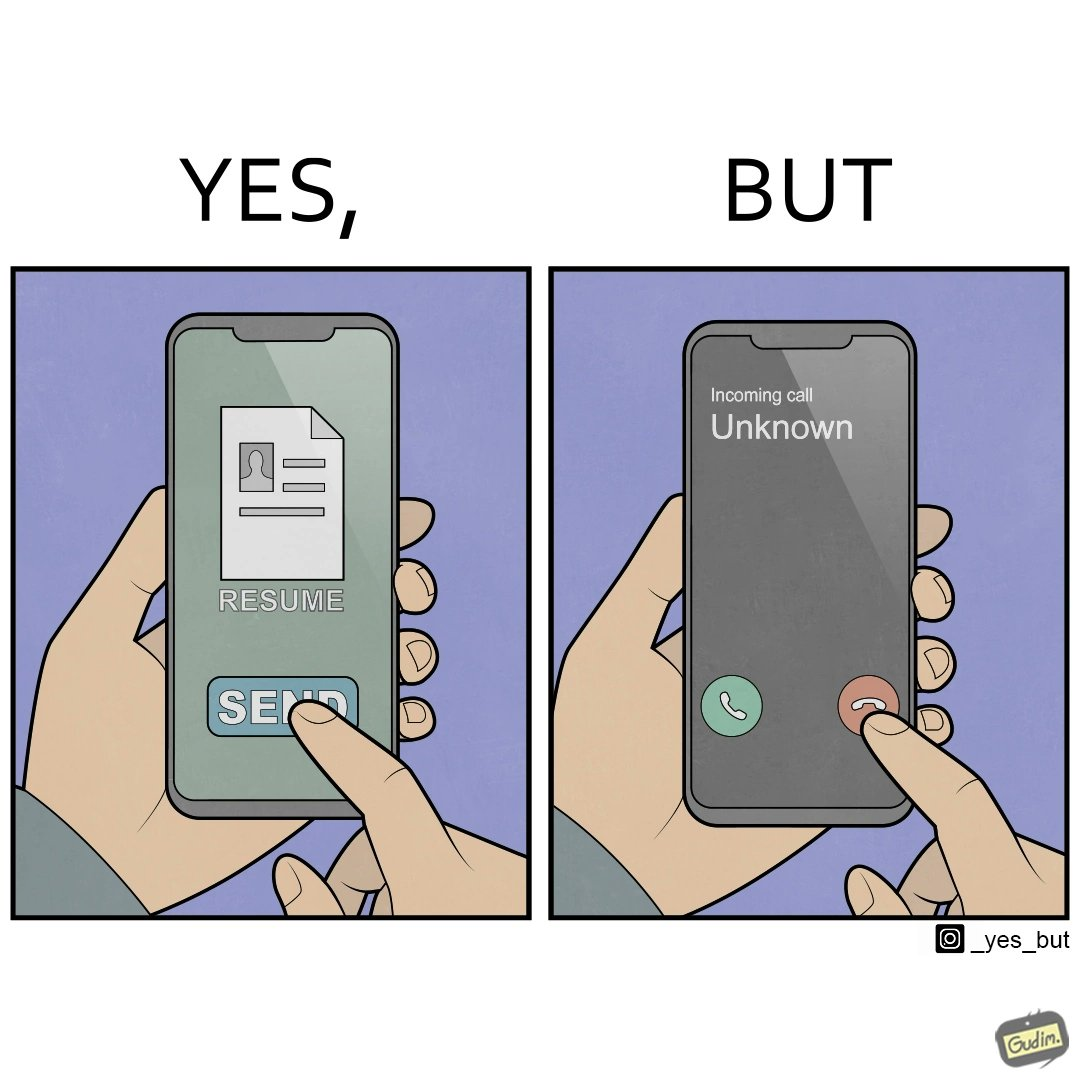Describe what you see in this image. The image is ironic, because on the left image the person is sending their resume to someone and on the right they are rejecting the unknown calls which might be some offer calls  or the person who sent the resume maybe tired of the spam calls after sending the resume which he sent seeking some new oppurtunities 